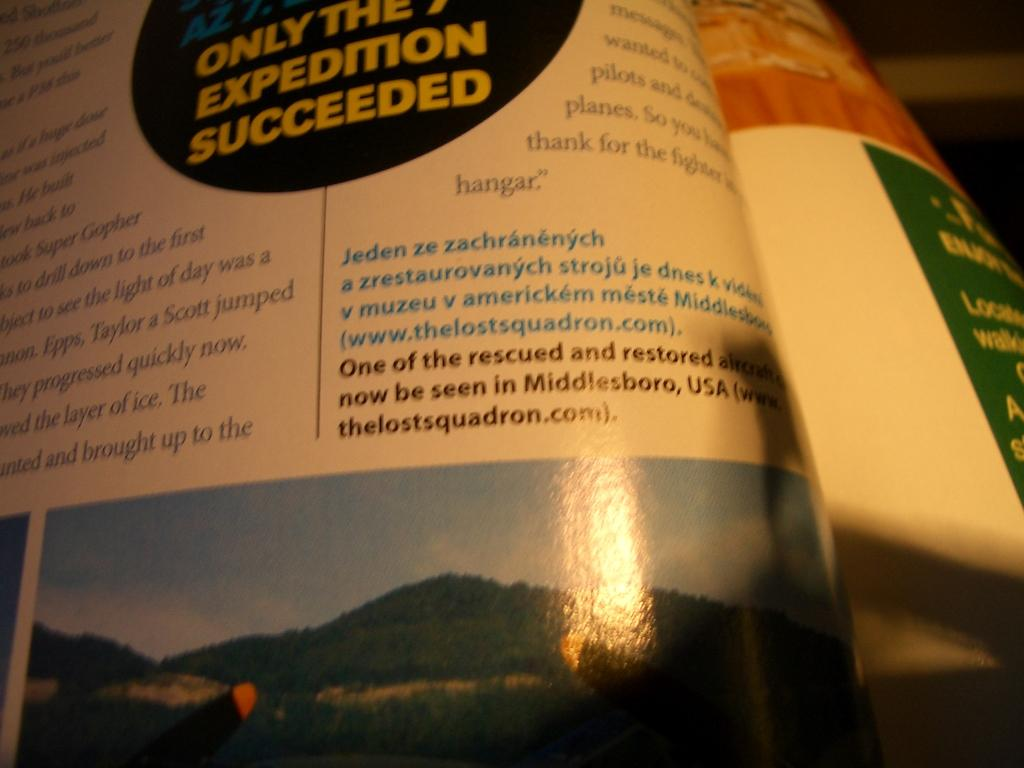<image>
Provide a brief description of the given image. a book that has a section that says 'only the 7th expedition succeeded' 